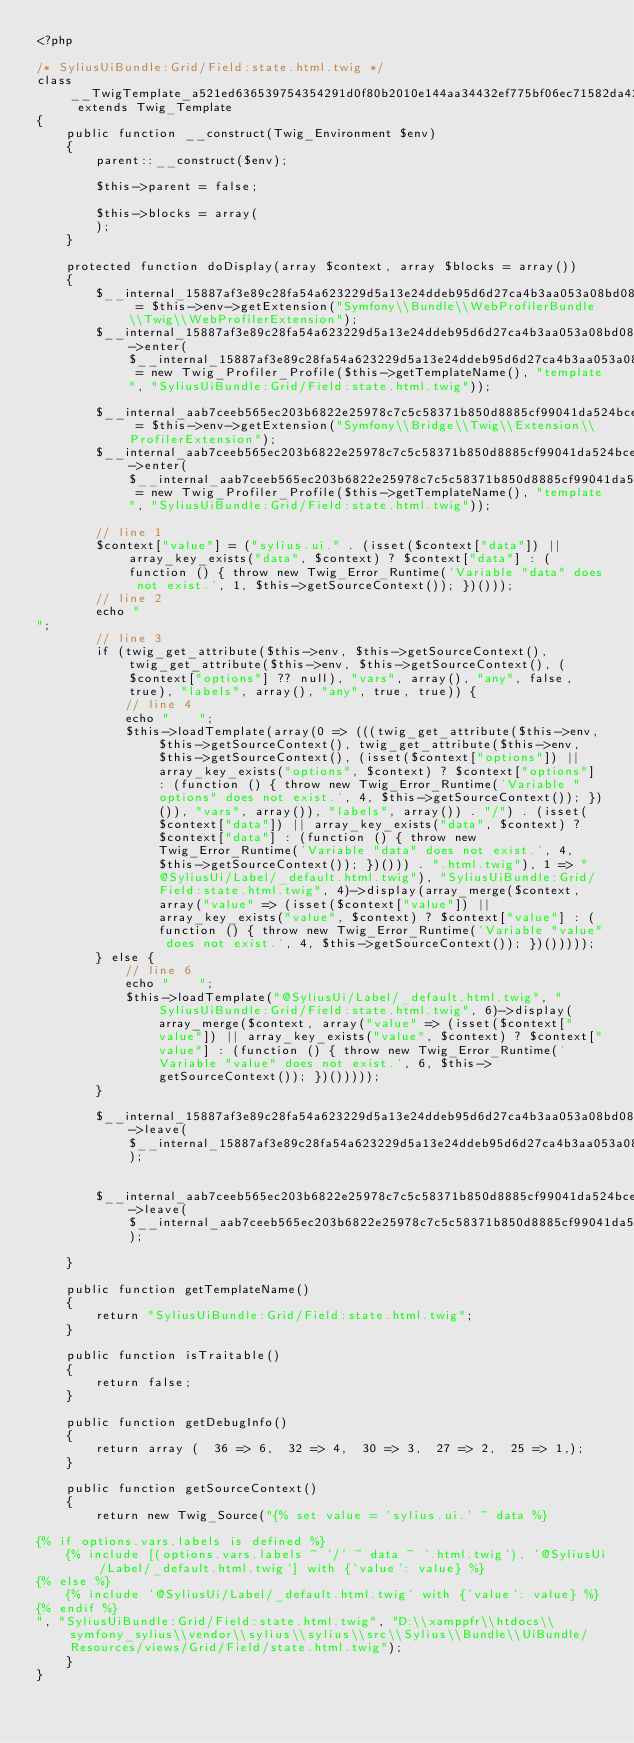Convert code to text. <code><loc_0><loc_0><loc_500><loc_500><_PHP_><?php

/* SyliusUiBundle:Grid/Field:state.html.twig */
class __TwigTemplate_a521ed636539754354291d0f80b2010e144aa34432ef775bf06ec71582da4246 extends Twig_Template
{
    public function __construct(Twig_Environment $env)
    {
        parent::__construct($env);

        $this->parent = false;

        $this->blocks = array(
        );
    }

    protected function doDisplay(array $context, array $blocks = array())
    {
        $__internal_15887af3e89c28fa54a623229d5a13e24ddeb95d6d27ca4b3aa053a08bd08786 = $this->env->getExtension("Symfony\\Bundle\\WebProfilerBundle\\Twig\\WebProfilerExtension");
        $__internal_15887af3e89c28fa54a623229d5a13e24ddeb95d6d27ca4b3aa053a08bd08786->enter($__internal_15887af3e89c28fa54a623229d5a13e24ddeb95d6d27ca4b3aa053a08bd08786_prof = new Twig_Profiler_Profile($this->getTemplateName(), "template", "SyliusUiBundle:Grid/Field:state.html.twig"));

        $__internal_aab7ceeb565ec203b6822e25978c7c5c58371b850d8885cf99041da524bce61f = $this->env->getExtension("Symfony\\Bridge\\Twig\\Extension\\ProfilerExtension");
        $__internal_aab7ceeb565ec203b6822e25978c7c5c58371b850d8885cf99041da524bce61f->enter($__internal_aab7ceeb565ec203b6822e25978c7c5c58371b850d8885cf99041da524bce61f_prof = new Twig_Profiler_Profile($this->getTemplateName(), "template", "SyliusUiBundle:Grid/Field:state.html.twig"));

        // line 1
        $context["value"] = ("sylius.ui." . (isset($context["data"]) || array_key_exists("data", $context) ? $context["data"] : (function () { throw new Twig_Error_Runtime('Variable "data" does not exist.', 1, $this->getSourceContext()); })()));
        // line 2
        echo "
";
        // line 3
        if (twig_get_attribute($this->env, $this->getSourceContext(), twig_get_attribute($this->env, $this->getSourceContext(), ($context["options"] ?? null), "vars", array(), "any", false, true), "labels", array(), "any", true, true)) {
            // line 4
            echo "    ";
            $this->loadTemplate(array(0 => (((twig_get_attribute($this->env, $this->getSourceContext(), twig_get_attribute($this->env, $this->getSourceContext(), (isset($context["options"]) || array_key_exists("options", $context) ? $context["options"] : (function () { throw new Twig_Error_Runtime('Variable "options" does not exist.', 4, $this->getSourceContext()); })()), "vars", array()), "labels", array()) . "/") . (isset($context["data"]) || array_key_exists("data", $context) ? $context["data"] : (function () { throw new Twig_Error_Runtime('Variable "data" does not exist.', 4, $this->getSourceContext()); })())) . ".html.twig"), 1 => "@SyliusUi/Label/_default.html.twig"), "SyliusUiBundle:Grid/Field:state.html.twig", 4)->display(array_merge($context, array("value" => (isset($context["value"]) || array_key_exists("value", $context) ? $context["value"] : (function () { throw new Twig_Error_Runtime('Variable "value" does not exist.', 4, $this->getSourceContext()); })()))));
        } else {
            // line 6
            echo "    ";
            $this->loadTemplate("@SyliusUi/Label/_default.html.twig", "SyliusUiBundle:Grid/Field:state.html.twig", 6)->display(array_merge($context, array("value" => (isset($context["value"]) || array_key_exists("value", $context) ? $context["value"] : (function () { throw new Twig_Error_Runtime('Variable "value" does not exist.', 6, $this->getSourceContext()); })()))));
        }
        
        $__internal_15887af3e89c28fa54a623229d5a13e24ddeb95d6d27ca4b3aa053a08bd08786->leave($__internal_15887af3e89c28fa54a623229d5a13e24ddeb95d6d27ca4b3aa053a08bd08786_prof);

        
        $__internal_aab7ceeb565ec203b6822e25978c7c5c58371b850d8885cf99041da524bce61f->leave($__internal_aab7ceeb565ec203b6822e25978c7c5c58371b850d8885cf99041da524bce61f_prof);

    }

    public function getTemplateName()
    {
        return "SyliusUiBundle:Grid/Field:state.html.twig";
    }

    public function isTraitable()
    {
        return false;
    }

    public function getDebugInfo()
    {
        return array (  36 => 6,  32 => 4,  30 => 3,  27 => 2,  25 => 1,);
    }

    public function getSourceContext()
    {
        return new Twig_Source("{% set value = 'sylius.ui.' ~ data %}

{% if options.vars.labels is defined %}
    {% include [(options.vars.labels ~ '/' ~ data ~ '.html.twig'), '@SyliusUi/Label/_default.html.twig'] with {'value': value} %}
{% else %}
    {% include '@SyliusUi/Label/_default.html.twig' with {'value': value} %}
{% endif %}
", "SyliusUiBundle:Grid/Field:state.html.twig", "D:\\xamppfr\\htdocs\\symfony_sylius\\vendor\\sylius\\sylius\\src\\Sylius\\Bundle\\UiBundle/Resources/views/Grid/Field/state.html.twig");
    }
}
</code> 